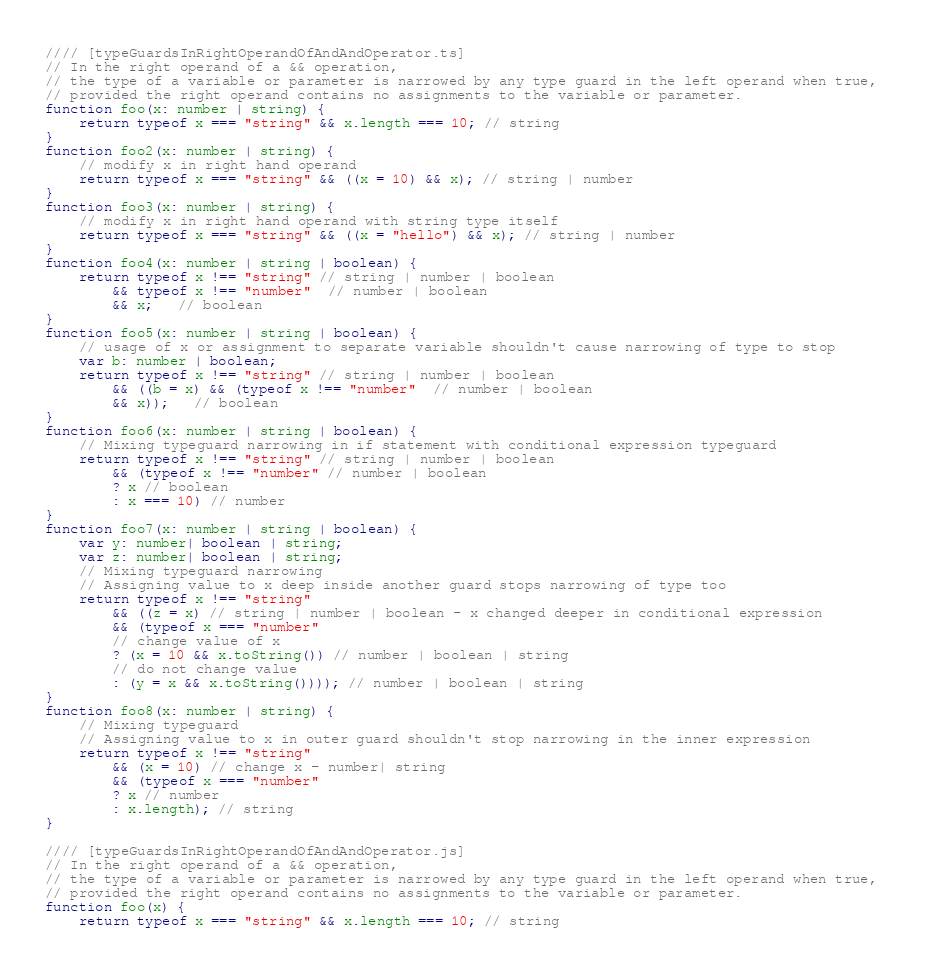<code> <loc_0><loc_0><loc_500><loc_500><_JavaScript_>//// [typeGuardsInRightOperandOfAndAndOperator.ts]
// In the right operand of a && operation, 
// the type of a variable or parameter is narrowed by any type guard in the left operand when true, 
// provided the right operand contains no assignments to the variable or parameter.
function foo(x: number | string) {
    return typeof x === "string" && x.length === 10; // string
}
function foo2(x: number | string) {
    // modify x in right hand operand
    return typeof x === "string" && ((x = 10) && x); // string | number
}
function foo3(x: number | string) {
    // modify x in right hand operand with string type itself
    return typeof x === "string" && ((x = "hello") && x); // string | number
}
function foo4(x: number | string | boolean) {
    return typeof x !== "string" // string | number | boolean
        && typeof x !== "number"  // number | boolean
        && x;   // boolean
}
function foo5(x: number | string | boolean) {
    // usage of x or assignment to separate variable shouldn't cause narrowing of type to stop
    var b: number | boolean;
    return typeof x !== "string" // string | number | boolean
        && ((b = x) && (typeof x !== "number"  // number | boolean
        && x));   // boolean
}
function foo6(x: number | string | boolean) {
    // Mixing typeguard narrowing in if statement with conditional expression typeguard
    return typeof x !== "string" // string | number | boolean
        && (typeof x !== "number" // number | boolean
        ? x // boolean
        : x === 10) // number 
}
function foo7(x: number | string | boolean) {
    var y: number| boolean | string;
    var z: number| boolean | string;
    // Mixing typeguard narrowing
    // Assigning value to x deep inside another guard stops narrowing of type too
    return typeof x !== "string"
        && ((z = x) // string | number | boolean - x changed deeper in conditional expression
        && (typeof x === "number"
        // change value of x
        ? (x = 10 && x.toString()) // number | boolean | string
        // do not change value
        : (y = x && x.toString()))); // number | boolean | string
}
function foo8(x: number | string) {
    // Mixing typeguard 
    // Assigning value to x in outer guard shouldn't stop narrowing in the inner expression
    return typeof x !== "string"
        && (x = 10) // change x - number| string
        && (typeof x === "number"
        ? x // number
        : x.length); // string
}

//// [typeGuardsInRightOperandOfAndAndOperator.js]
// In the right operand of a && operation, 
// the type of a variable or parameter is narrowed by any type guard in the left operand when true, 
// provided the right operand contains no assignments to the variable or parameter.
function foo(x) {
    return typeof x === "string" && x.length === 10; // string</code> 